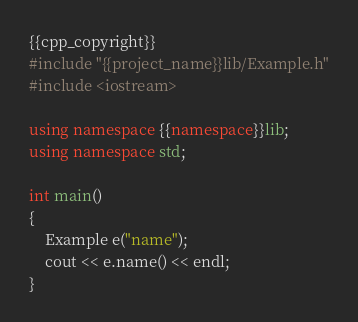Convert code to text. <code><loc_0><loc_0><loc_500><loc_500><_C++_>{{cpp_copyright}}
#include "{{project_name}}lib/Example.h"
#include <iostream>

using namespace {{namespace}}lib;
using namespace std;

int main()
{
    Example e("name");
    cout << e.name() << endl;
}
</code> 